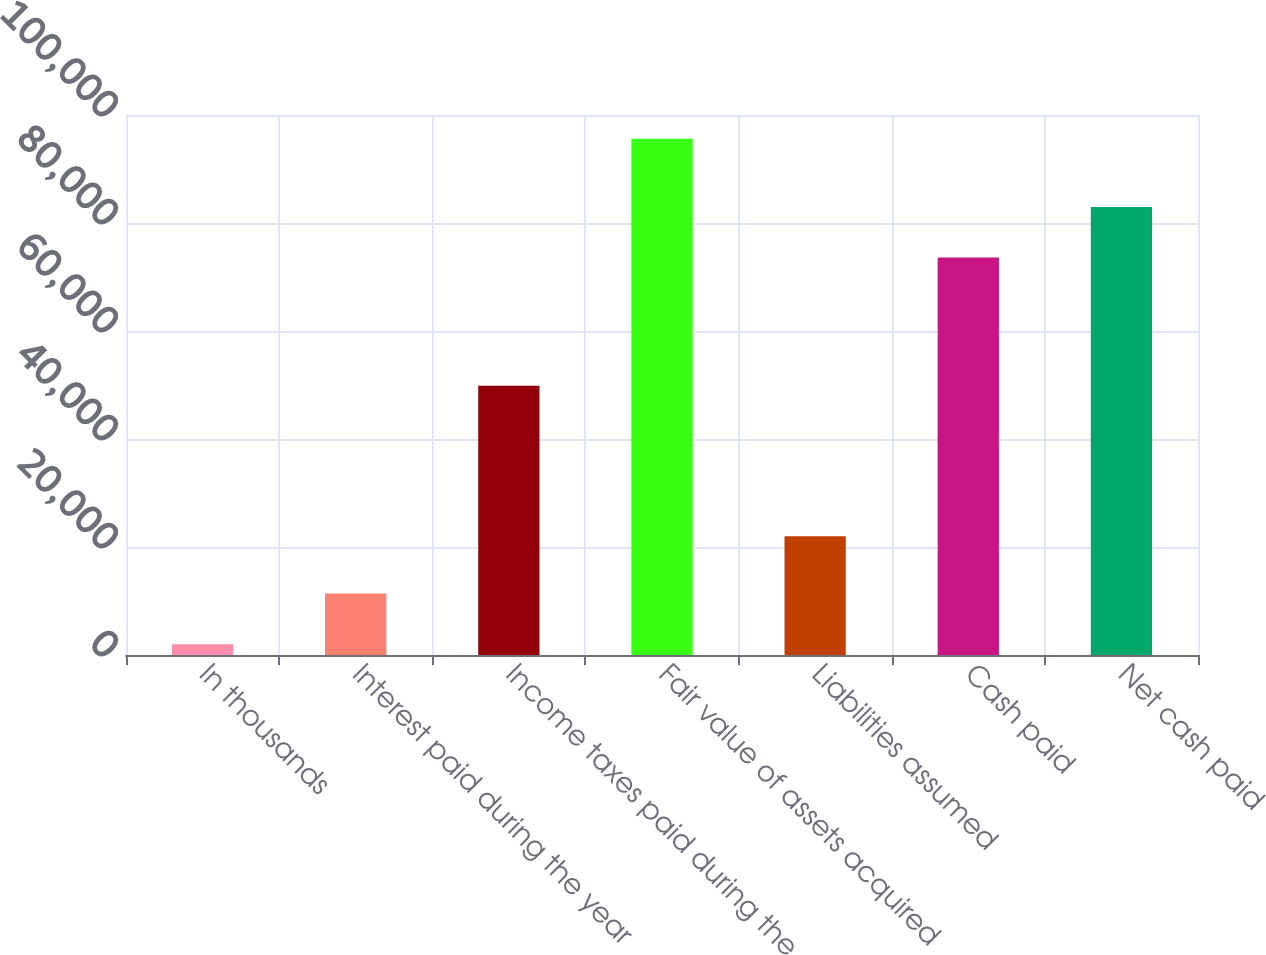Convert chart to OTSL. <chart><loc_0><loc_0><loc_500><loc_500><bar_chart><fcel>In thousands<fcel>Interest paid during the year<fcel>Income taxes paid during the<fcel>Fair value of assets acquired<fcel>Liabilities assumed<fcel>Cash paid<fcel>Net cash paid<nl><fcel>2007<fcel>11366.3<fcel>49841<fcel>95600<fcel>22000<fcel>73600<fcel>82959.3<nl></chart> 